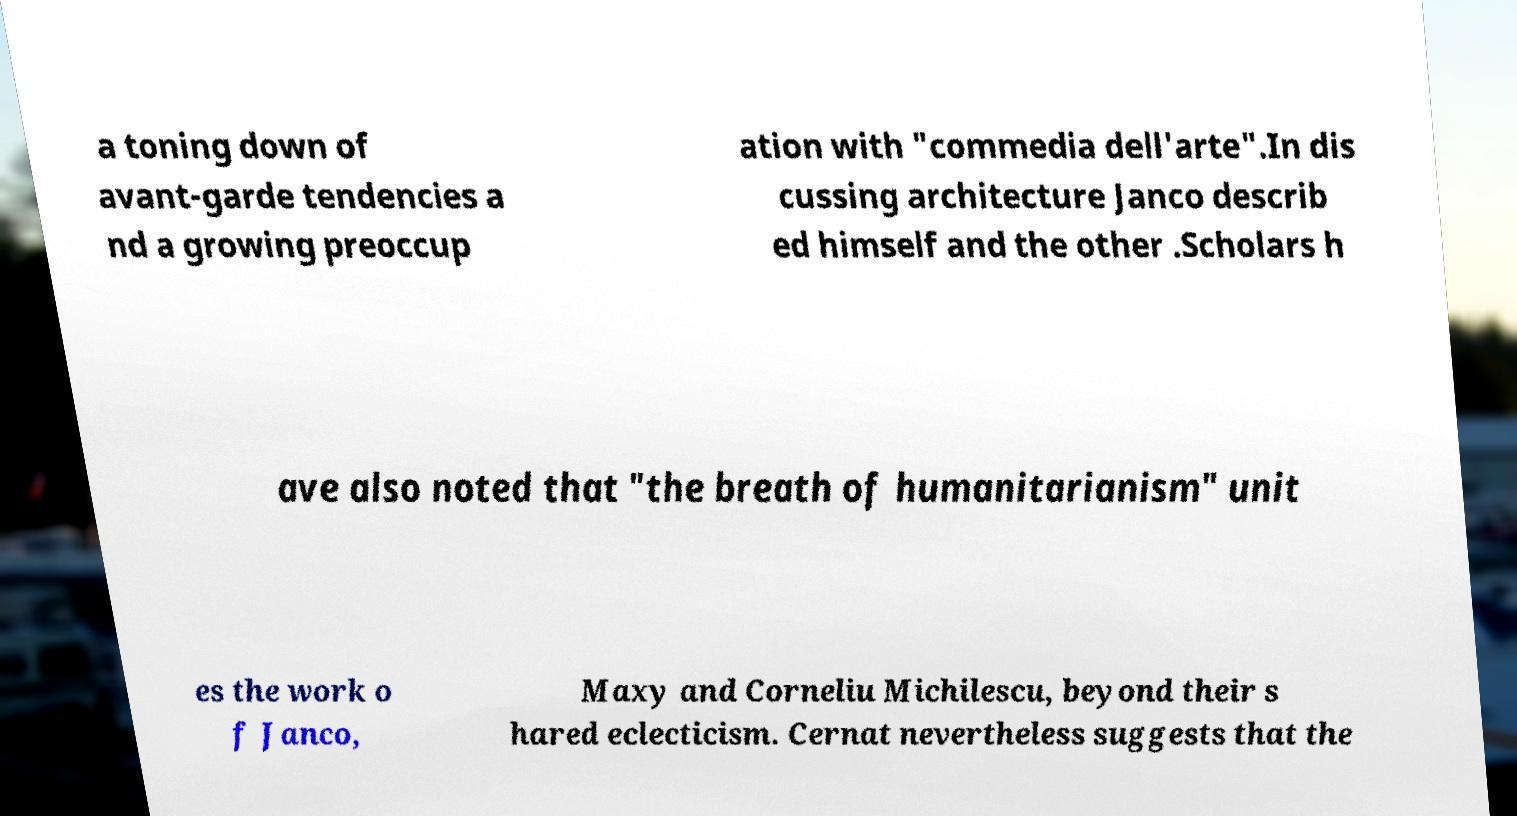What messages or text are displayed in this image? I need them in a readable, typed format. a toning down of avant-garde tendencies a nd a growing preoccup ation with "commedia dell'arte".In dis cussing architecture Janco describ ed himself and the other .Scholars h ave also noted that "the breath of humanitarianism" unit es the work o f Janco, Maxy and Corneliu Michilescu, beyond their s hared eclecticism. Cernat nevertheless suggests that the 